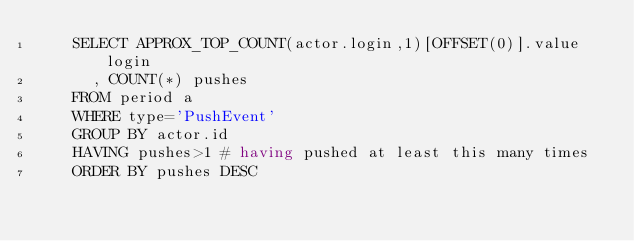<code> <loc_0><loc_0><loc_500><loc_500><_SQL_>    SELECT APPROX_TOP_COUNT(actor.login,1)[OFFSET(0)].value login
      , COUNT(*) pushes
    FROM period a
    WHERE type='PushEvent'
    GROUP BY actor.id
    HAVING pushes>1 # having pushed at least this many times
    ORDER BY pushes DESC
</code> 